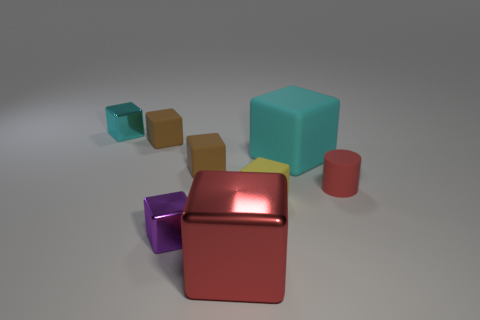Subtract 5 blocks. How many blocks are left? 2 Subtract all yellow cubes. How many cubes are left? 6 Subtract all tiny metallic cubes. How many cubes are left? 5 Subtract all purple blocks. Subtract all green cylinders. How many blocks are left? 6 Add 1 big objects. How many objects exist? 9 Subtract all cylinders. How many objects are left? 7 Subtract all brown matte objects. Subtract all big cyan things. How many objects are left? 5 Add 7 tiny yellow matte cubes. How many tiny yellow matte cubes are left? 8 Add 2 cylinders. How many cylinders exist? 3 Subtract 0 brown cylinders. How many objects are left? 8 